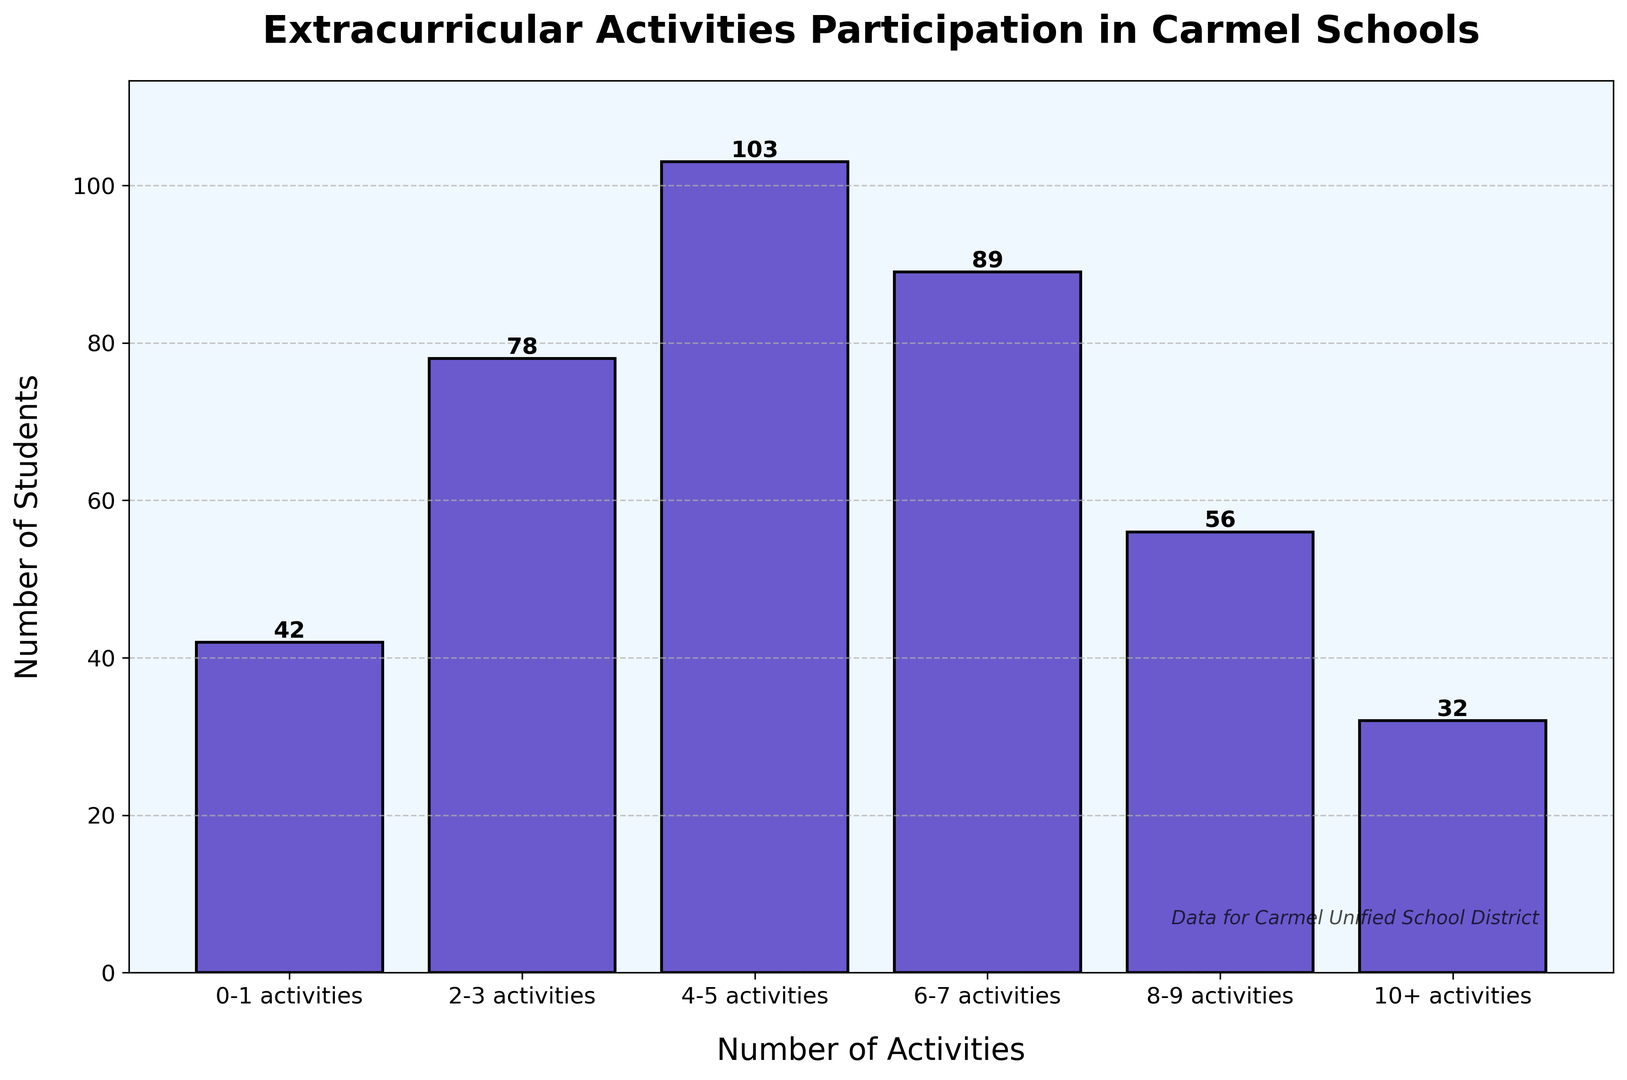Which frequency category has the most students participating in extracurricular activities? The frequency category with the most students can be identified by looking at the bar with the highest height. The highest bar represents the "4-5 activities" category.
Answer: 4-5 activities How many students participate in more than 7 extracurricular activities? To find the number of students participating in more than 7 activities, sum the numbers for the "8-9 activities" and "10+ activities" categories: 56 (8-9 activities) + 32 (10+ activities) = 88.
Answer: 88 What is the difference in student participation between the "0-1 activities" and "4-5 activities" categories? The difference can be obtained by subtracting the number of students in the "0-1 activities" category from the "4-5 activities" category: 103 (4-5 activities) - 42 (0-1 activities) = 61.
Answer: 61 Which frequency categories have fewer students participating in extracurricular activities than the "6-7 activities" category? Compare each category's student count with the "6-7 activities" category (89 students). The categories with fewer students are "0-1 activities" (42 students), "2-3 activities" (78 students), "8-9 activities" (56 students), and "10+ activities" (32 students).
Answer: 0-1 activities, 2-3 activities, 8-9 activities, 10+ activities What is the average number of students participating per frequency category? Calculate the sum of students in all categories and divide by the number of categories: (42 + 78 + 103 + 89 + 56 + 32) / 6 = 400 / 6 ≈ 66.67.
Answer: 66.67 How many students participate in up to 5 extracurricular activities? Sum the number of students in the "0-1 activities", "2-3 activities", and "4-5 activities" categories: 42 + 78 + 103 = 223.
Answer: 223 Which category has the closest number of students to the average student participation across all categories? The average participation is approximately 66.67 students. Compare each category's student count to this value. The "2-3 activities" category has 78 students, which is closest to 66.67.
Answer: 2-3 activities What is the combined total number of students in the "0-1 activities" and "10+ activities" categories? Sum the students in these two categories: 42 (0-1 activities) + 32 (10+ activities) = 74.
Answer: 74 Is the number of students in the "4-5 activities" category greater than or less than double the number in the "10+ activities" category? Compare the number of students in "4-5 activities" (103) with double the number in "10+ activities" (32 * 2 = 64). 103 is greater than 64.
Answer: Greater Which frequency categories have more than double the number of students participating compared to the "0-1 activities" category? Double the number of students in "0-1 activities" is 42 * 2 = 84. Categories with more than 84 students are "4-5 activities" (103) and "6-7 activities" (89).
Answer: 4-5 activities, 6-7 activities 